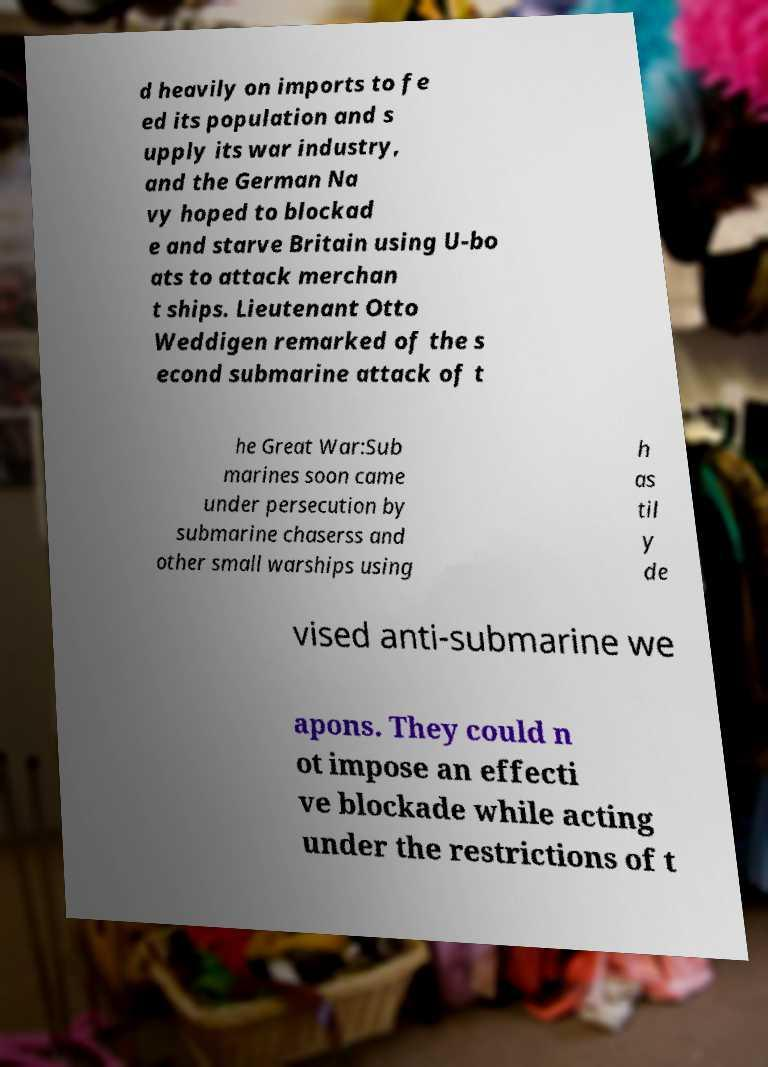For documentation purposes, I need the text within this image transcribed. Could you provide that? d heavily on imports to fe ed its population and s upply its war industry, and the German Na vy hoped to blockad e and starve Britain using U-bo ats to attack merchan t ships. Lieutenant Otto Weddigen remarked of the s econd submarine attack of t he Great War:Sub marines soon came under persecution by submarine chaserss and other small warships using h as til y de vised anti-submarine we apons. They could n ot impose an effecti ve blockade while acting under the restrictions of t 